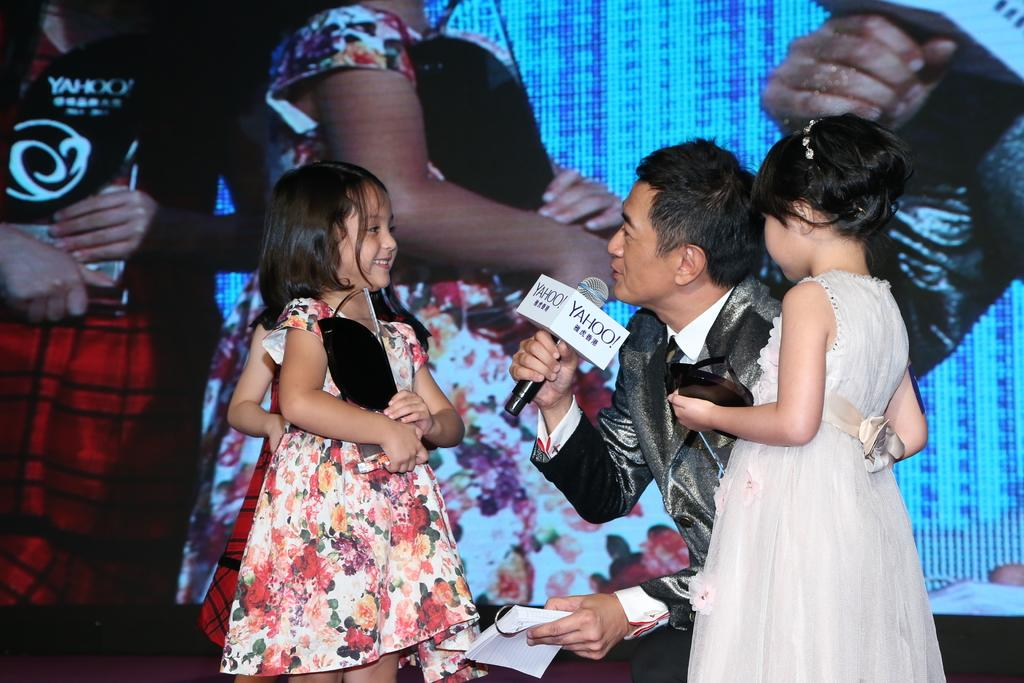Who is the main subject in the image? There is a girl in the image. What is the girl holding? The girl is holding a prize. Who else is present in the image? There is a man in the image. What is the man holding? The man is holding a microphone. What can be seen in the background of the image? There are other people and a screen in the background of the image. What type of peace symbol can be seen in the image? There is no peace symbol present in the image. Can you describe the key that the girl is using to unlock the prize? There is no key visible in the image; the girl is simply holding a prize. 